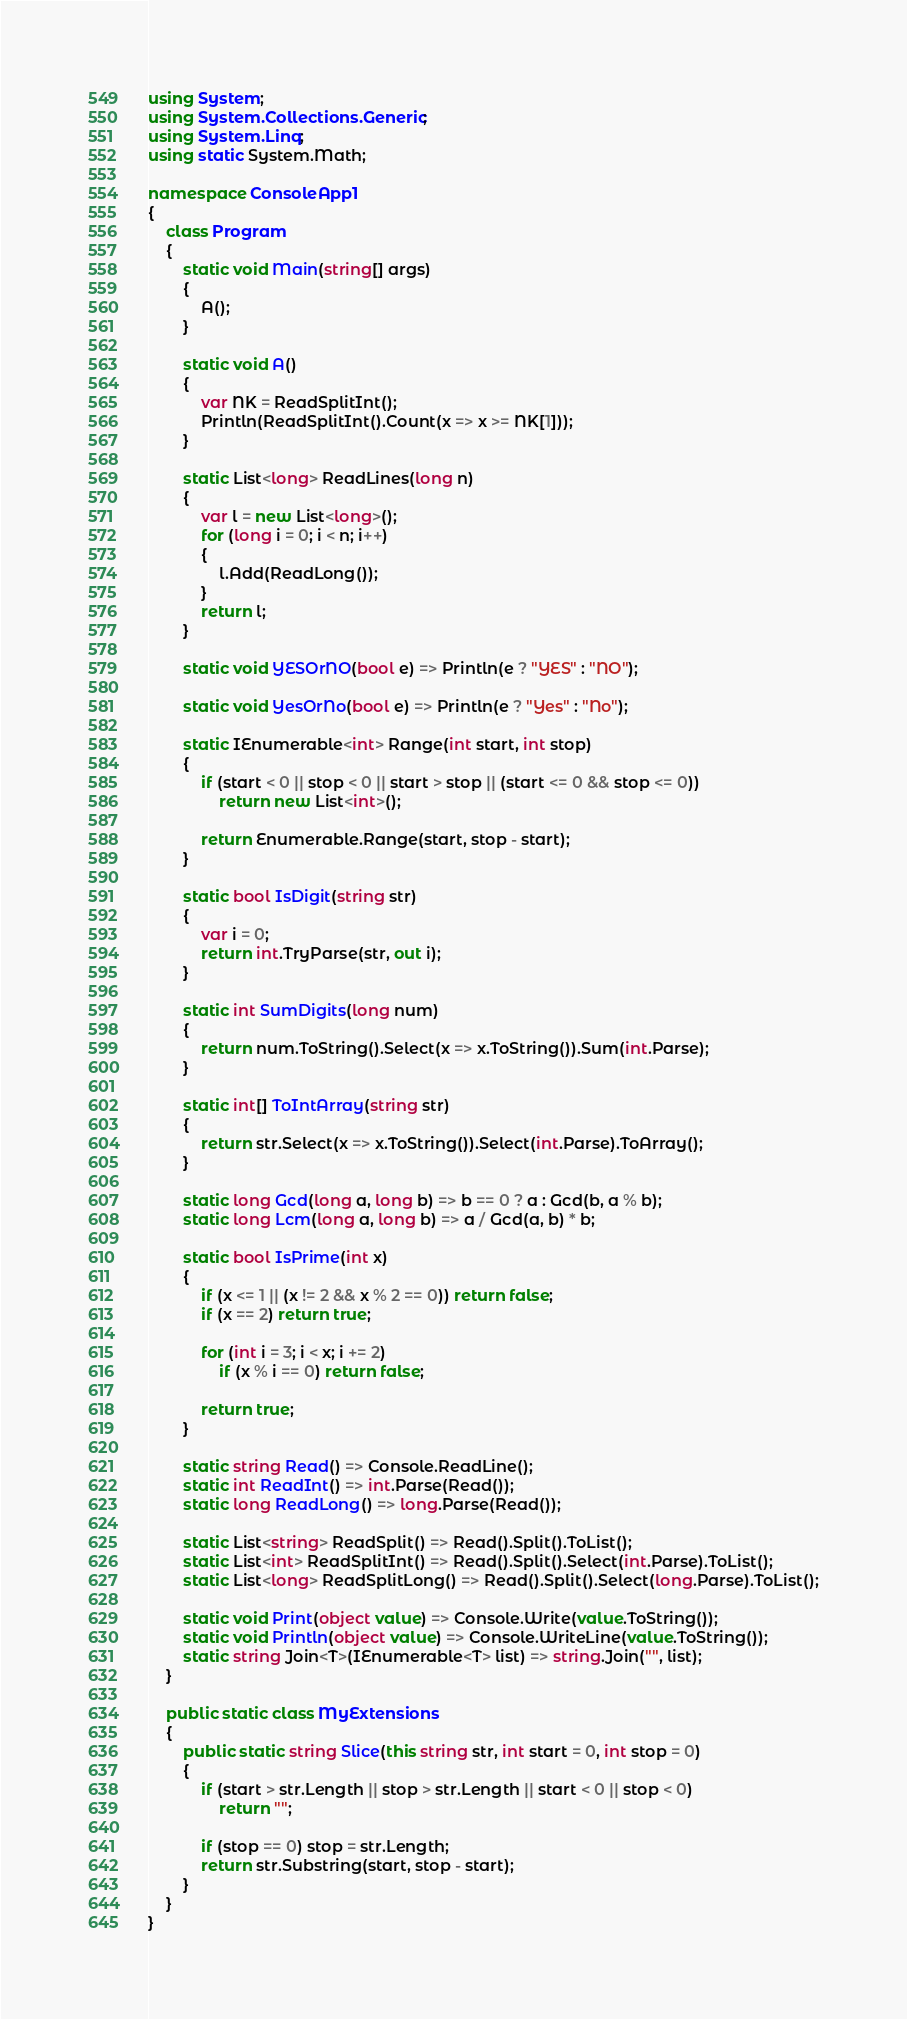<code> <loc_0><loc_0><loc_500><loc_500><_C#_>using System;
using System.Collections.Generic;
using System.Linq;
using static System.Math;

namespace ConsoleApp1
{
    class Program
    {
        static void Main(string[] args)
        {
            A();
        }

        static void A()
        {
            var NK = ReadSplitInt();
            Println(ReadSplitInt().Count(x => x >= NK[1]));
        }

        static List<long> ReadLines(long n)
        {
            var l = new List<long>();
            for (long i = 0; i < n; i++)
            {
                l.Add(ReadLong());
            }
            return l;
        }

        static void YESOrNO(bool e) => Println(e ? "YES" : "NO");

        static void YesOrNo(bool e) => Println(e ? "Yes" : "No");

        static IEnumerable<int> Range(int start, int stop)
        {
            if (start < 0 || stop < 0 || start > stop || (start <= 0 && stop <= 0))
                return new List<int>();

            return Enumerable.Range(start, stop - start);
        }

        static bool IsDigit(string str)
        {
            var i = 0;
            return int.TryParse(str, out i);
        }

        static int SumDigits(long num)
        {
            return num.ToString().Select(x => x.ToString()).Sum(int.Parse);
        }

        static int[] ToIntArray(string str)
        {
            return str.Select(x => x.ToString()).Select(int.Parse).ToArray();
        }

        static long Gcd(long a, long b) => b == 0 ? a : Gcd(b, a % b);
        static long Lcm(long a, long b) => a / Gcd(a, b) * b;

        static bool IsPrime(int x)
        {
            if (x <= 1 || (x != 2 && x % 2 == 0)) return false;
            if (x == 2) return true;

            for (int i = 3; i < x; i += 2)
                if (x % i == 0) return false;

            return true;
        }

        static string Read() => Console.ReadLine();
        static int ReadInt() => int.Parse(Read());
        static long ReadLong() => long.Parse(Read());

        static List<string> ReadSplit() => Read().Split().ToList();
        static List<int> ReadSplitInt() => Read().Split().Select(int.Parse).ToList();
        static List<long> ReadSplitLong() => Read().Split().Select(long.Parse).ToList();

        static void Print(object value) => Console.Write(value.ToString());
        static void Println(object value) => Console.WriteLine(value.ToString());
        static string Join<T>(IEnumerable<T> list) => string.Join("", list);
    }

    public static class MyExtensions
    {
        public static string Slice(this string str, int start = 0, int stop = 0)
        {
            if (start > str.Length || stop > str.Length || start < 0 || stop < 0)
                return "";

            if (stop == 0) stop = str.Length;
            return str.Substring(start, stop - start);
        }
    }
}

</code> 